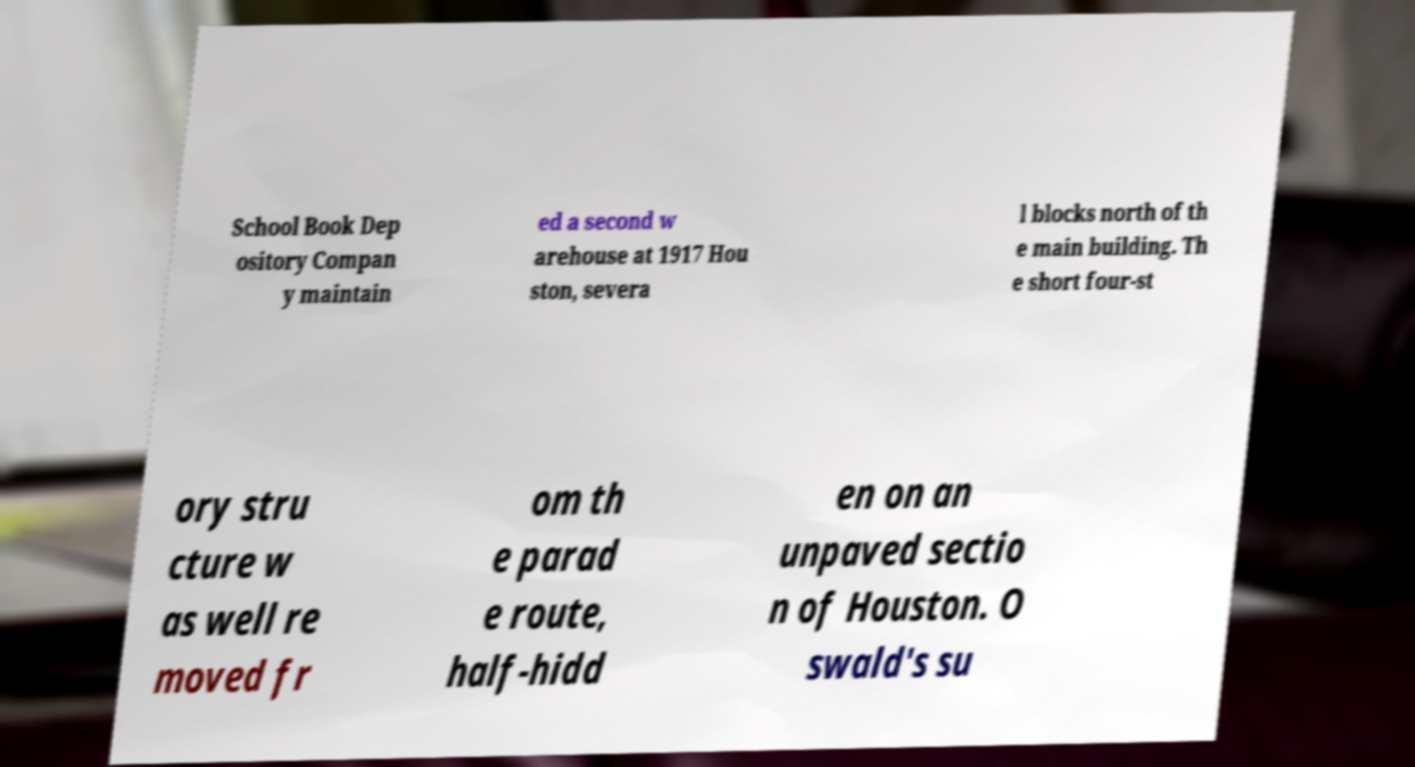Could you extract and type out the text from this image? School Book Dep ository Compan y maintain ed a second w arehouse at 1917 Hou ston, severa l blocks north of th e main building. Th e short four-st ory stru cture w as well re moved fr om th e parad e route, half-hidd en on an unpaved sectio n of Houston. O swald's su 